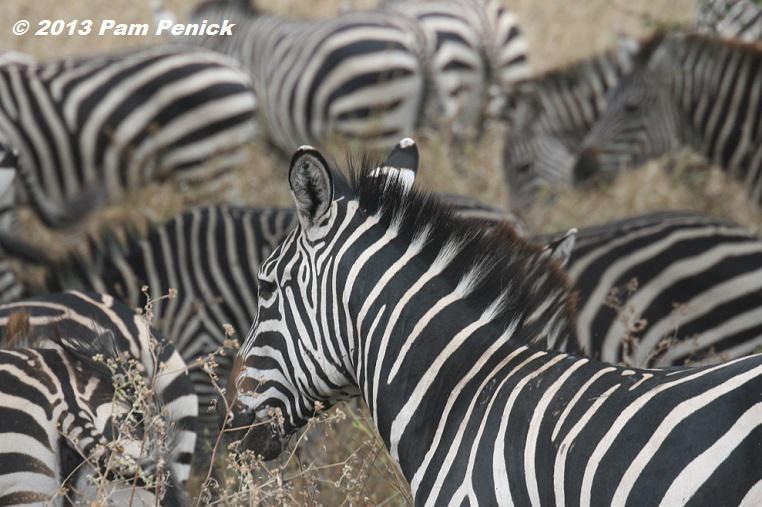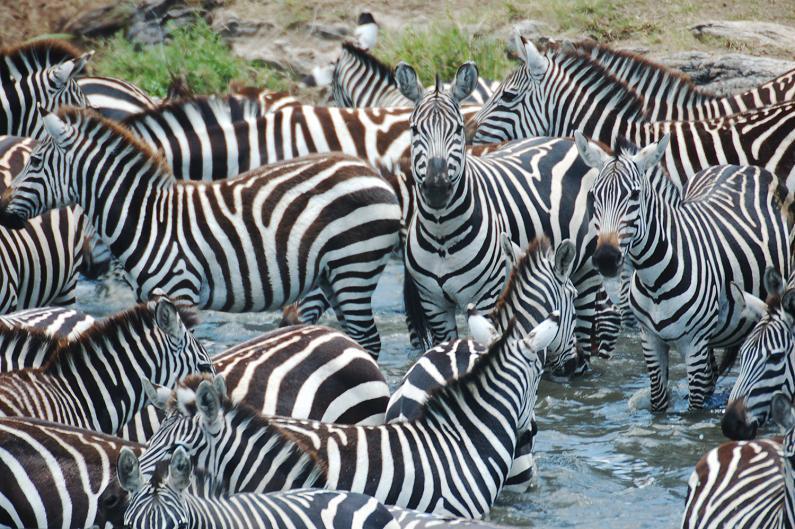The first image is the image on the left, the second image is the image on the right. For the images displayed, is the sentence "In at least one image there are at least 8 zebra standing in tall grass." factually correct? Answer yes or no. Yes. 